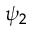<formula> <loc_0><loc_0><loc_500><loc_500>\psi _ { 2 }</formula> 